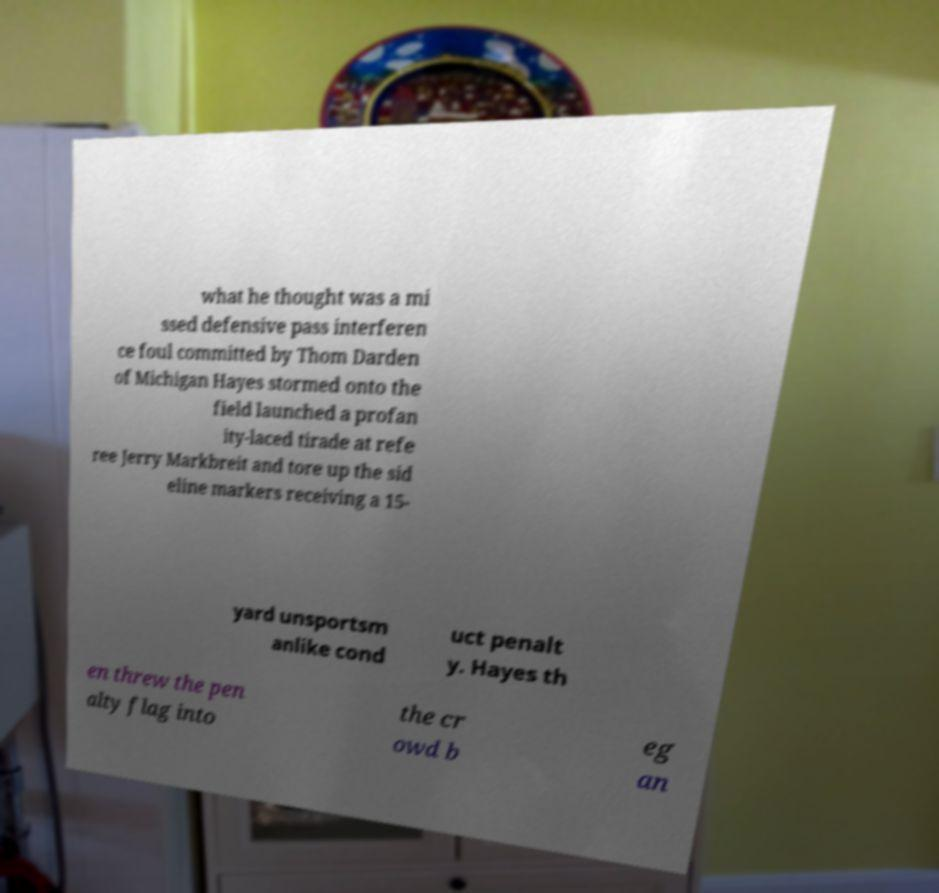Could you assist in decoding the text presented in this image and type it out clearly? what he thought was a mi ssed defensive pass interferen ce foul committed by Thom Darden of Michigan Hayes stormed onto the field launched a profan ity-laced tirade at refe ree Jerry Markbreit and tore up the sid eline markers receiving a 15- yard unsportsm anlike cond uct penalt y. Hayes th en threw the pen alty flag into the cr owd b eg an 